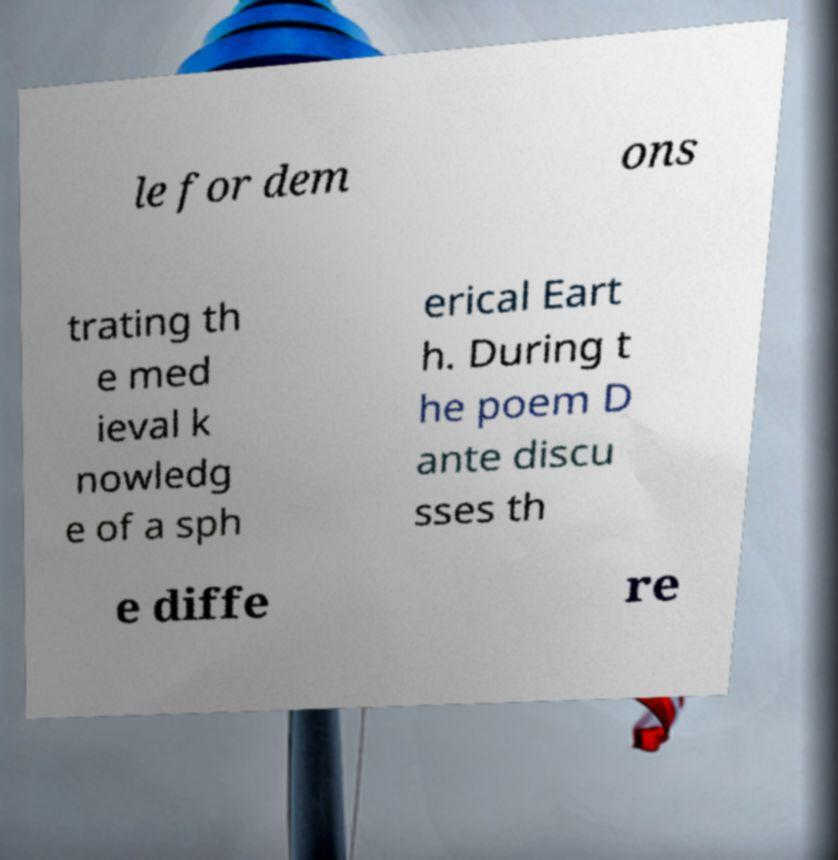Can you accurately transcribe the text from the provided image for me? le for dem ons trating th e med ieval k nowledg e of a sph erical Eart h. During t he poem D ante discu sses th e diffe re 